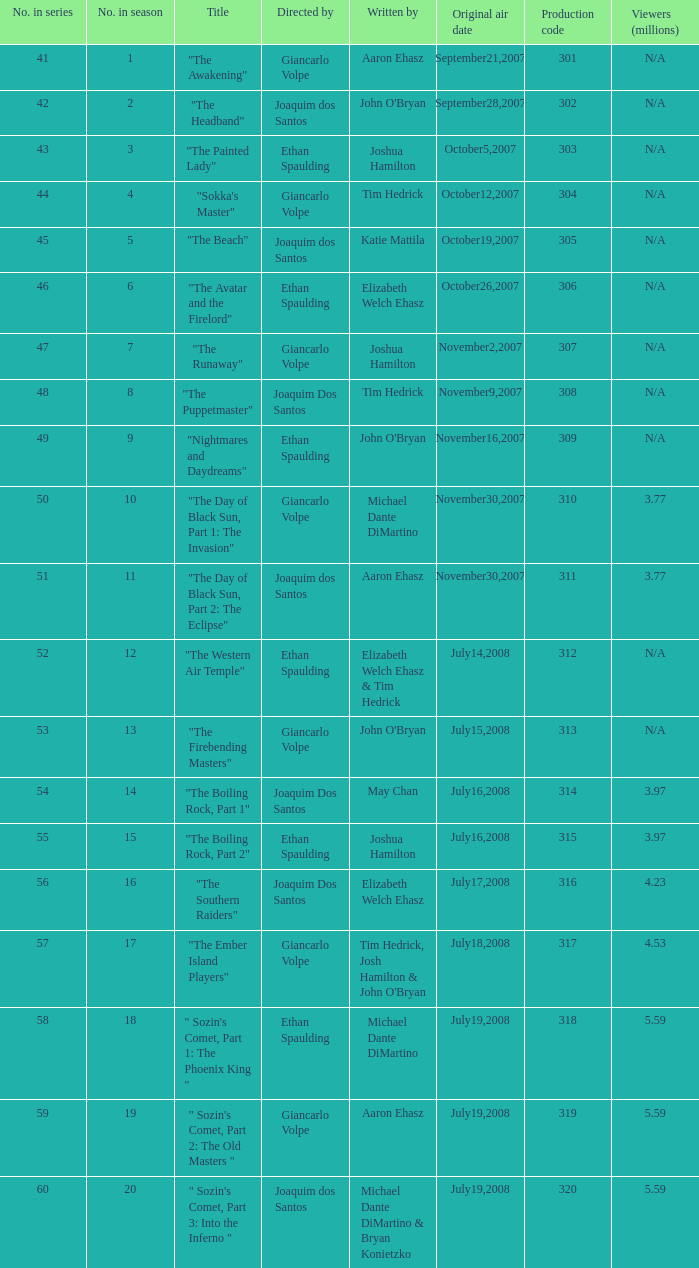What season has an episode written by john o'bryan and directed by ethan spaulding? 9.0. 